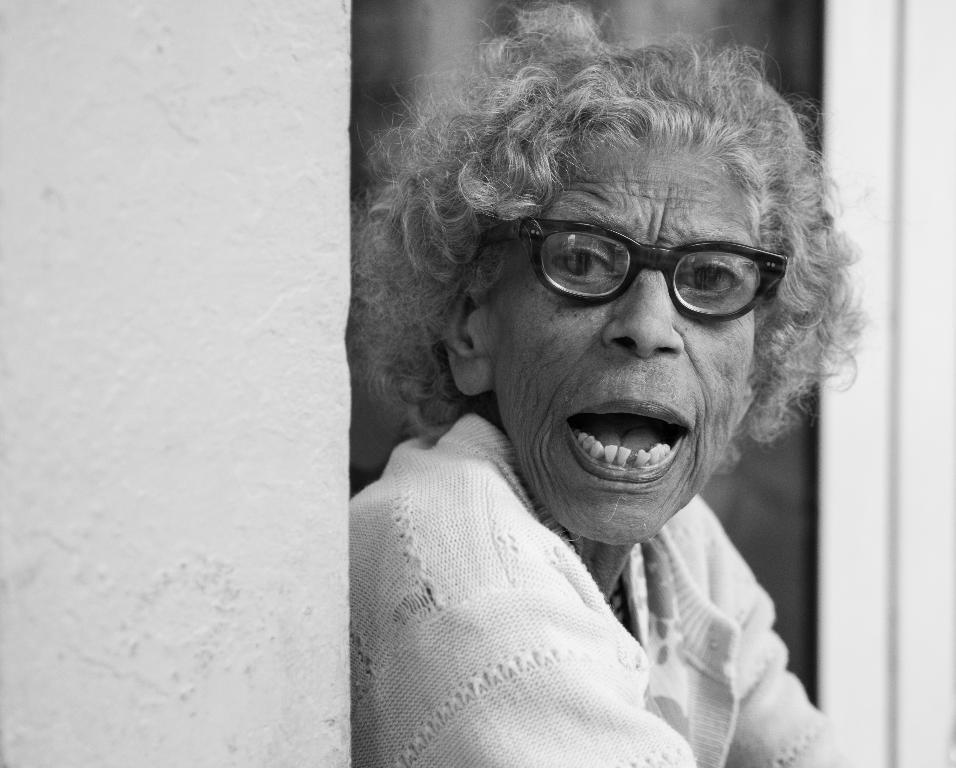Could you give a brief overview of what you see in this image? In this image we can see a speaking something. She is wearing a sweater and a spectacle. 